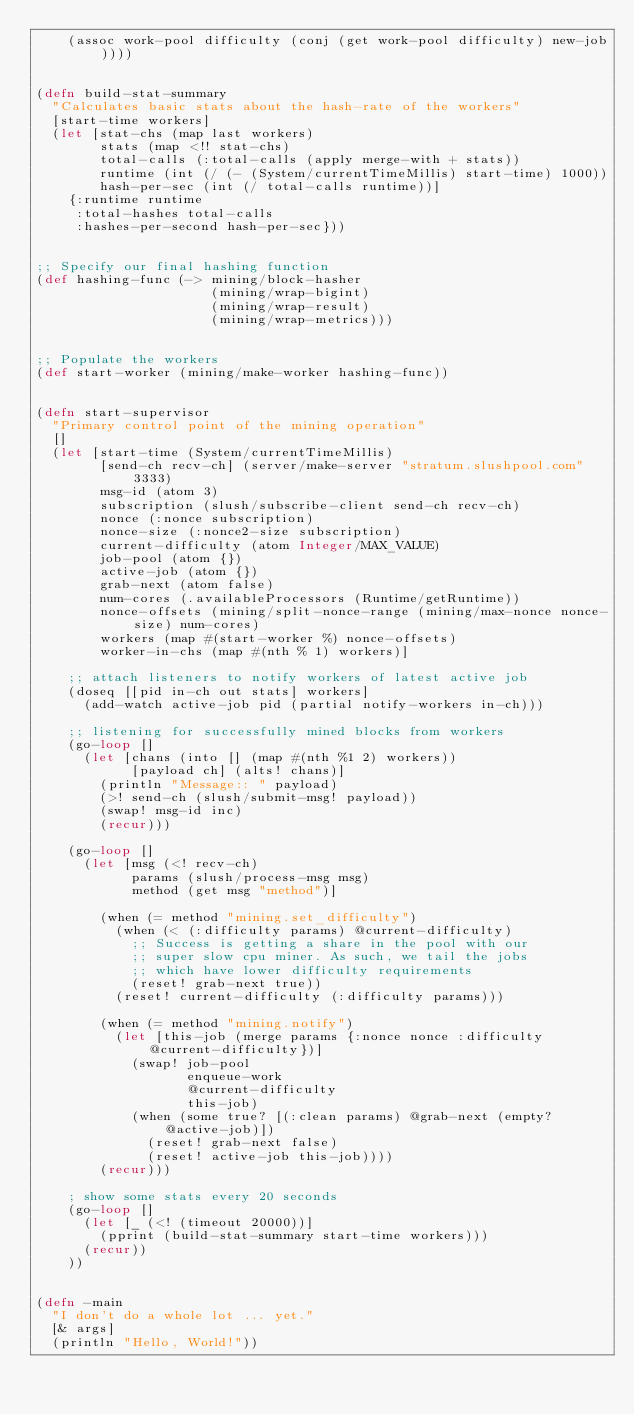Convert code to text. <code><loc_0><loc_0><loc_500><loc_500><_Clojure_>    (assoc work-pool difficulty (conj (get work-pool difficulty) new-job))))


(defn build-stat-summary
  "Calculates basic stats about the hash-rate of the workers"
  [start-time workers]
  (let [stat-chs (map last workers)
        stats (map <!! stat-chs)
        total-calls (:total-calls (apply merge-with + stats))
        runtime (int (/ (- (System/currentTimeMillis) start-time) 1000))
        hash-per-sec (int (/ total-calls runtime))]
    {:runtime runtime
     :total-hashes total-calls
     :hashes-per-second hash-per-sec}))


;; Specify our final hashing function
(def hashing-func (-> mining/block-hasher
                      (mining/wrap-bigint)
                      (mining/wrap-result)
                      (mining/wrap-metrics)))


;; Populate the workers
(def start-worker (mining/make-worker hashing-func))


(defn start-supervisor
  "Primary control point of the mining operation"
  []
  (let [start-time (System/currentTimeMillis)
        [send-ch recv-ch] (server/make-server "stratum.slushpool.com" 3333)
        msg-id (atom 3)
        subscription (slush/subscribe-client send-ch recv-ch)
        nonce (:nonce subscription)
        nonce-size (:nonce2-size subscription)
        current-difficulty (atom Integer/MAX_VALUE)
        job-pool (atom {})
        active-job (atom {})
        grab-next (atom false)
        num-cores (.availableProcessors (Runtime/getRuntime))
        nonce-offsets (mining/split-nonce-range (mining/max-nonce nonce-size) num-cores)
        workers (map #(start-worker %) nonce-offsets)
        worker-in-chs (map #(nth % 1) workers)]

    ;; attach listeners to notify workers of latest active job
    (doseq [[pid in-ch out stats] workers]
      (add-watch active-job pid (partial notify-workers in-ch)))

    ;; listening for successfully mined blocks from workers
    (go-loop []
      (let [chans (into [] (map #(nth %1 2) workers))
            [payload ch] (alts! chans)]
        (println "Message:: " payload)
        (>! send-ch (slush/submit-msg! payload))
        (swap! msg-id inc)
        (recur)))

    (go-loop []
      (let [msg (<! recv-ch)
            params (slush/process-msg msg)
            method (get msg "method")]

        (when (= method "mining.set_difficulty")
          (when (< (:difficulty params) @current-difficulty)
            ;; Success is getting a share in the pool with our
            ;; super slow cpu miner. As such, we tail the jobs
            ;; which have lower difficulty requirements
            (reset! grab-next true))
          (reset! current-difficulty (:difficulty params)))

        (when (= method "mining.notify")
          (let [this-job (merge params {:nonce nonce :difficulty @current-difficulty})]
            (swap! job-pool
                   enqueue-work
                   @current-difficulty
                   this-job)
            (when (some true? [(:clean params) @grab-next (empty? @active-job)])
              (reset! grab-next false)
              (reset! active-job this-job))))
        (recur)))

    ; show some stats every 20 seconds
    (go-loop []
      (let [_ (<! (timeout 20000))]
        (pprint (build-stat-summary start-time workers)))
      (recur))
    ))


(defn -main
  "I don't do a whole lot ... yet."
  [& args]
  (println "Hello, World!"))</code> 